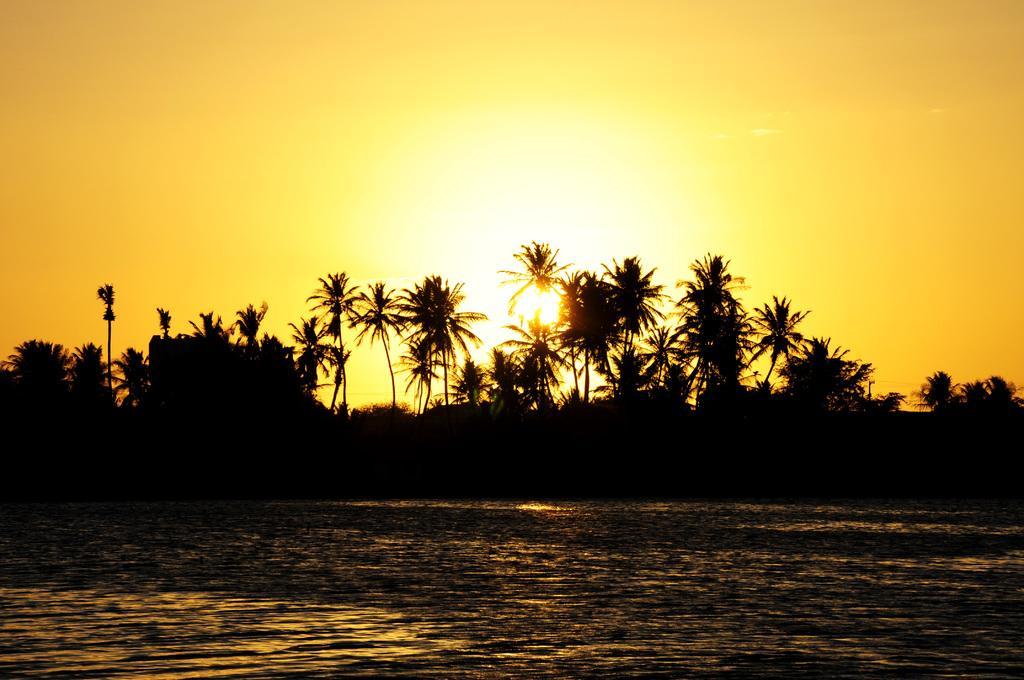Please provide a concise description of this image. In this picture there are trees. At the top there is sky and there is a sun. At the bottom there is water. 